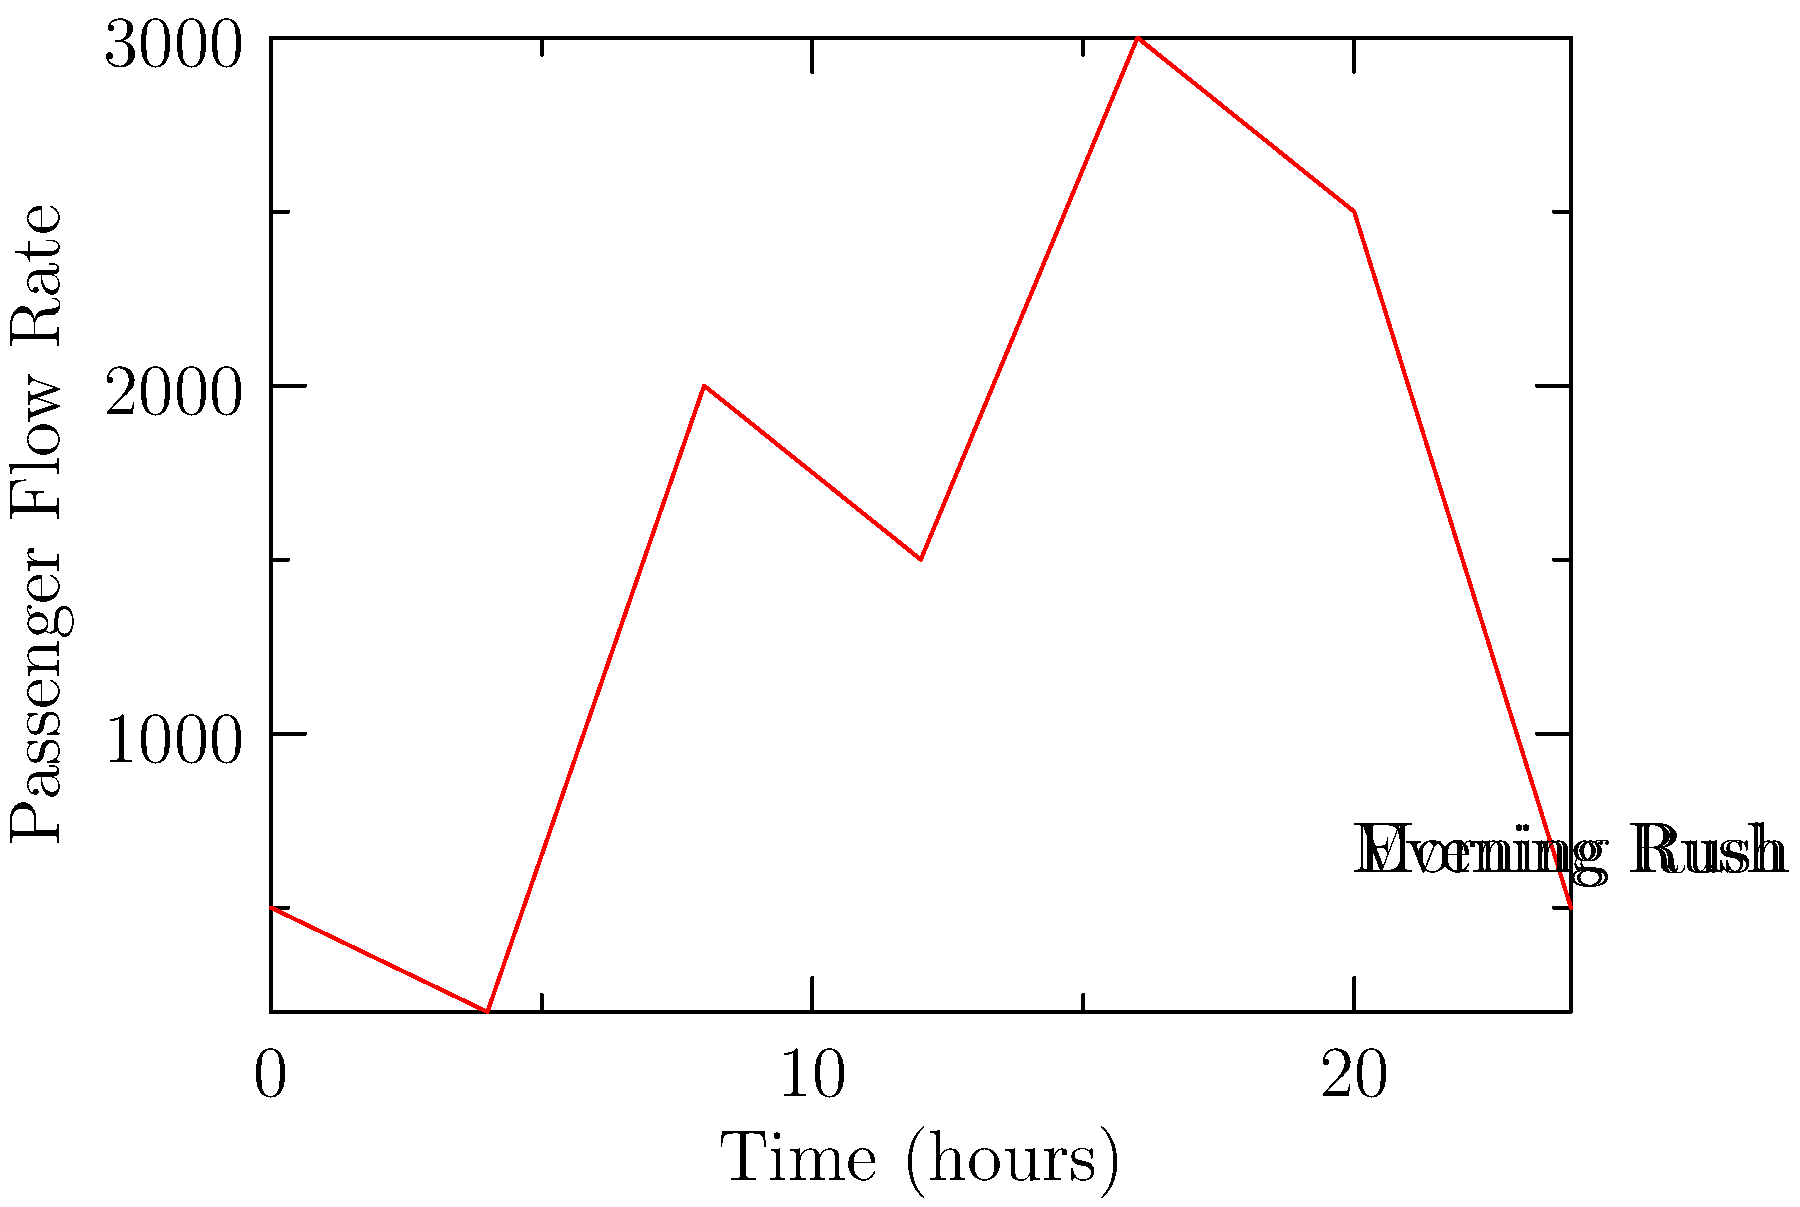Analyze the graph showing passenger flow rates in a subway system over a 24-hour period. Identify the two peak congestion points and calculate the difference in passenger flow rates between these peaks. How might this information influence safety measures and system improvements? To answer this question, we need to follow these steps:

1. Identify the two peak congestion points:
   - Morning peak: Around 8 hours (8:00 AM), with a flow rate of approximately 2000 passengers/hour
   - Evening peak: Around 16 hours (4:00 PM), with a flow rate of approximately 3000 passengers/hour

2. Calculate the difference in passenger flow rates:
   Evening peak - Morning peak = 3000 - 2000 = 1000 passengers/hour

3. Analyzing the impact on safety measures and system improvements:
   a) The higher evening peak suggests a need for increased safety measures during this time, such as:
      - More frequent safety inspections
      - Additional staff for crowd control
      - Enhanced emergency response preparedness

   b) System improvements could include:
      - Increasing train frequency during peak hours, especially in the evening
      - Implementing express services to reduce congestion
      - Expanding platform capacity at major stations

   c) The difference in peak flow rates (1000 passengers/hour) indicates a need for flexible resource allocation throughout the day to maintain safety and efficiency.

   d) The data can be used to optimize maintenance schedules, performing non-essential work during off-peak hours to minimize disruptions.

   e) Safety drills and staff training should be focused on managing high-volume scenarios, particularly those matching the evening peak conditions.
Answer: Evening peak: 3000 passengers/hour, morning peak: 2000 passengers/hour. Difference: 1000 passengers/hour. Influences: increased safety measures, flexible resource allocation, optimized maintenance, and targeted safety training. 